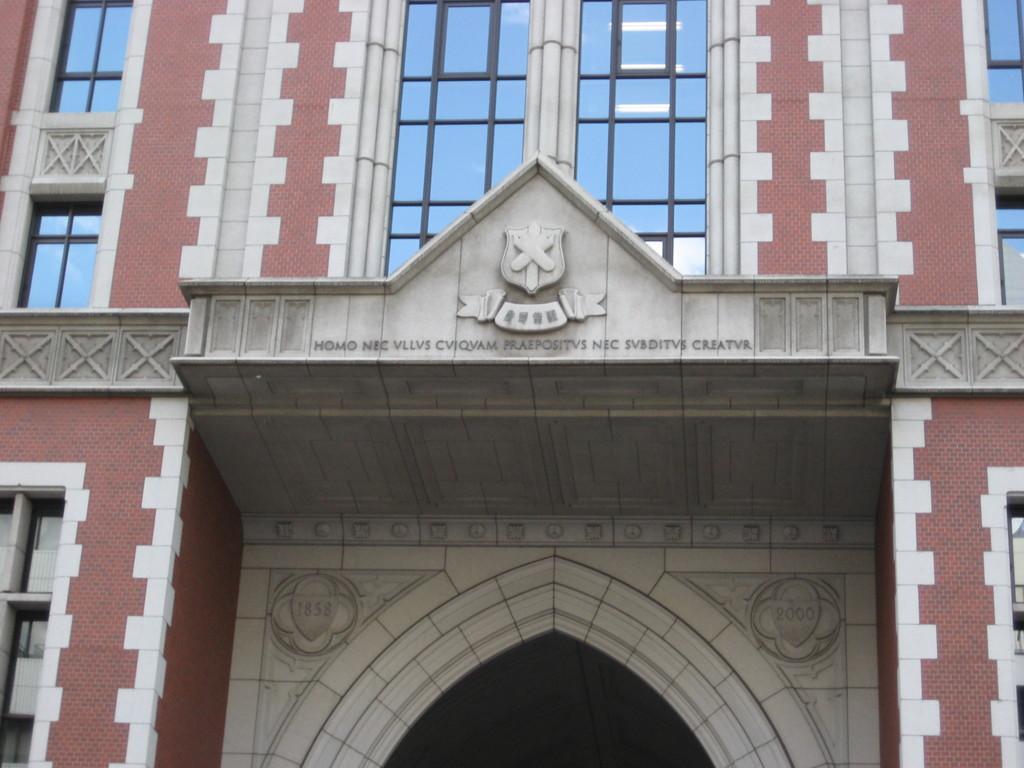Describe this image in one or two sentences. In the image there is a building with walls, pillars, glass windows, arches and walls with logo and something on it. And also there are numbers on the walls. 